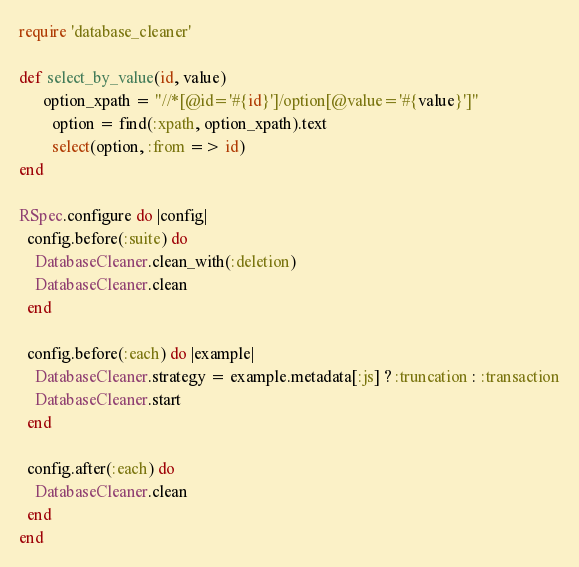Convert code to text. <code><loc_0><loc_0><loc_500><loc_500><_Ruby_>require 'database_cleaner'

def select_by_value(id, value)
	  option_xpath = "//*[@id='#{id}']/option[@value='#{value}']"
		option = find(:xpath, option_xpath).text
		select(option, :from => id)
end

RSpec.configure do |config|
  config.before(:suite) do
    DatabaseCleaner.clean_with(:deletion)
    DatabaseCleaner.clean
  end

  config.before(:each) do |example|
    DatabaseCleaner.strategy = example.metadata[:js] ? :truncation : :transaction
    DatabaseCleaner.start
  end

  config.after(:each) do
    DatabaseCleaner.clean
  end
end

</code> 